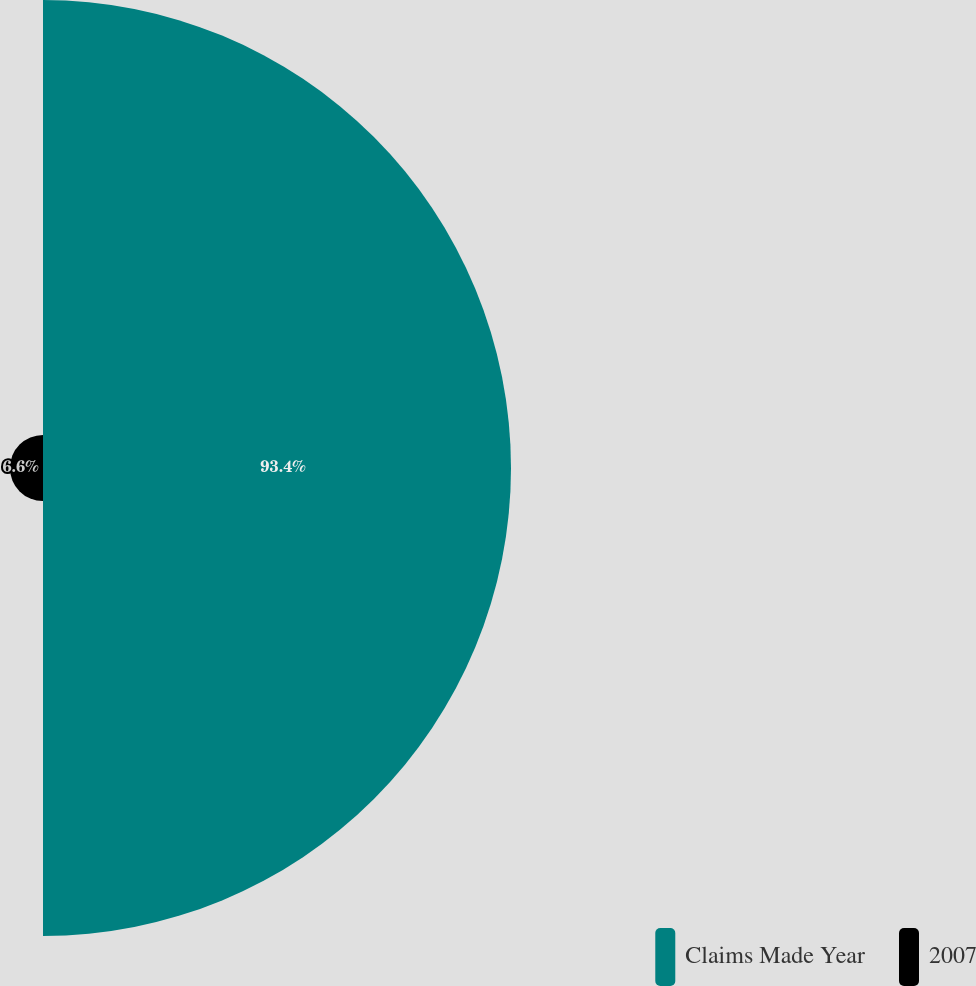Convert chart. <chart><loc_0><loc_0><loc_500><loc_500><pie_chart><fcel>Claims Made Year<fcel>2007<nl><fcel>93.4%<fcel>6.6%<nl></chart> 